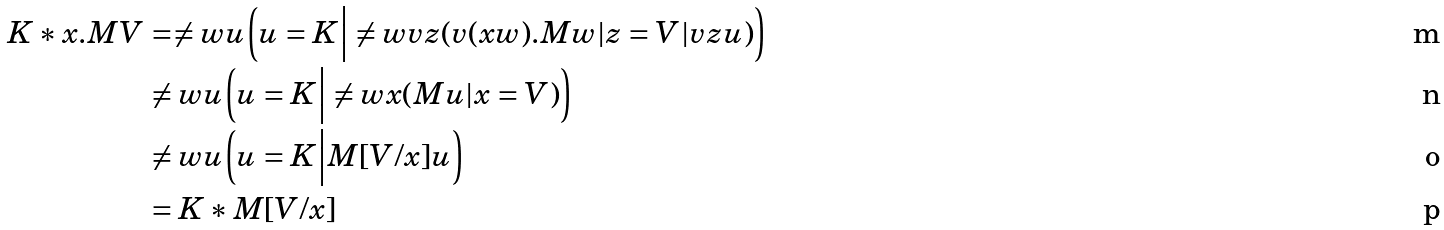Convert formula to latex. <formula><loc_0><loc_0><loc_500><loc_500>K * x . M V & = \ne w { u } \Big ( u = K \Big | \ne w { v z } ( v ( x w ) . M w | z = V | v z u ) \Big ) \\ & \ne w { u } \Big ( u = K \Big | \ne w { x } ( M u | x = V ) \Big ) \\ & \ne w { u } \Big ( u = K \Big | M [ V / x ] u \Big ) \\ & = K * M [ V / x ]</formula> 